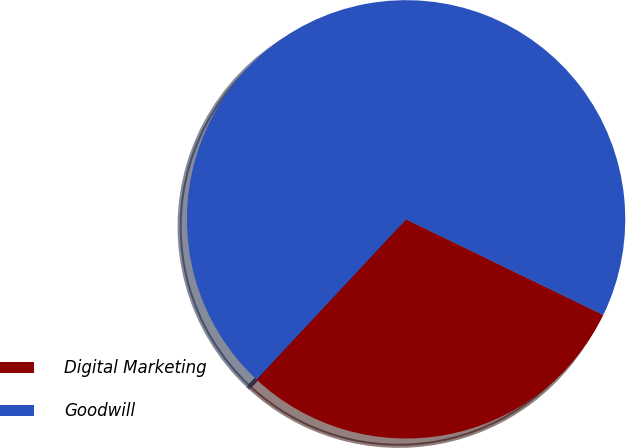Convert chart. <chart><loc_0><loc_0><loc_500><loc_500><pie_chart><fcel>Digital Marketing<fcel>Goodwill<nl><fcel>29.77%<fcel>70.23%<nl></chart> 